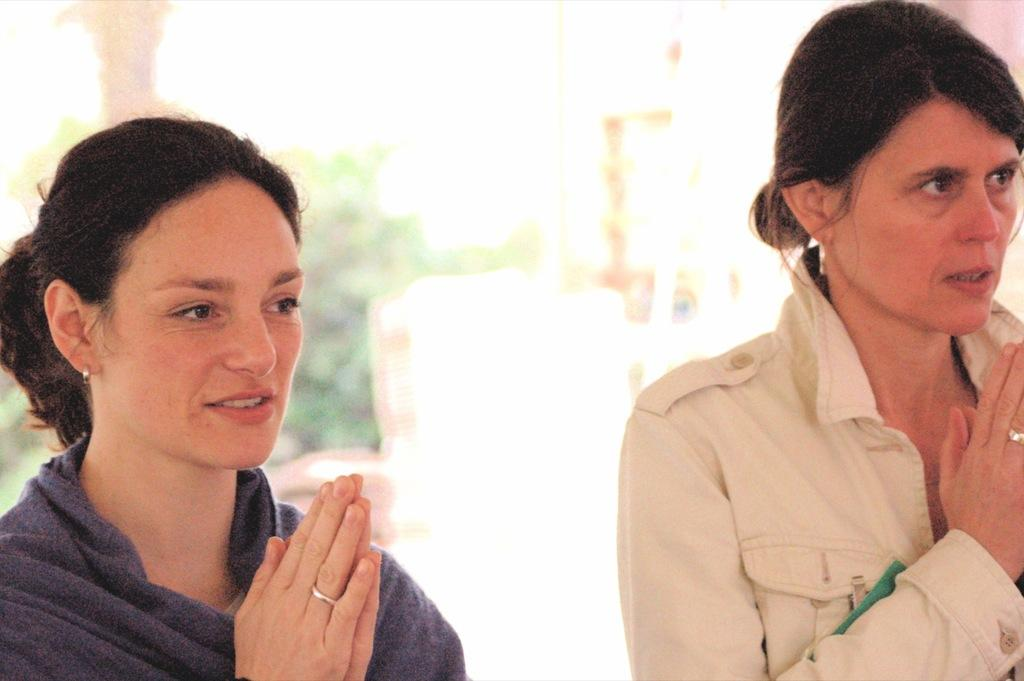How many people are in the image? There are two women in the image. What are the women doing in the image? The women are standing. Can you describe the background of the image? The background of the image is blurred. What type of pest can be seen crawling on the women's clothes in the image? There are no pests visible in the image; the women are standing without any visible pests. 